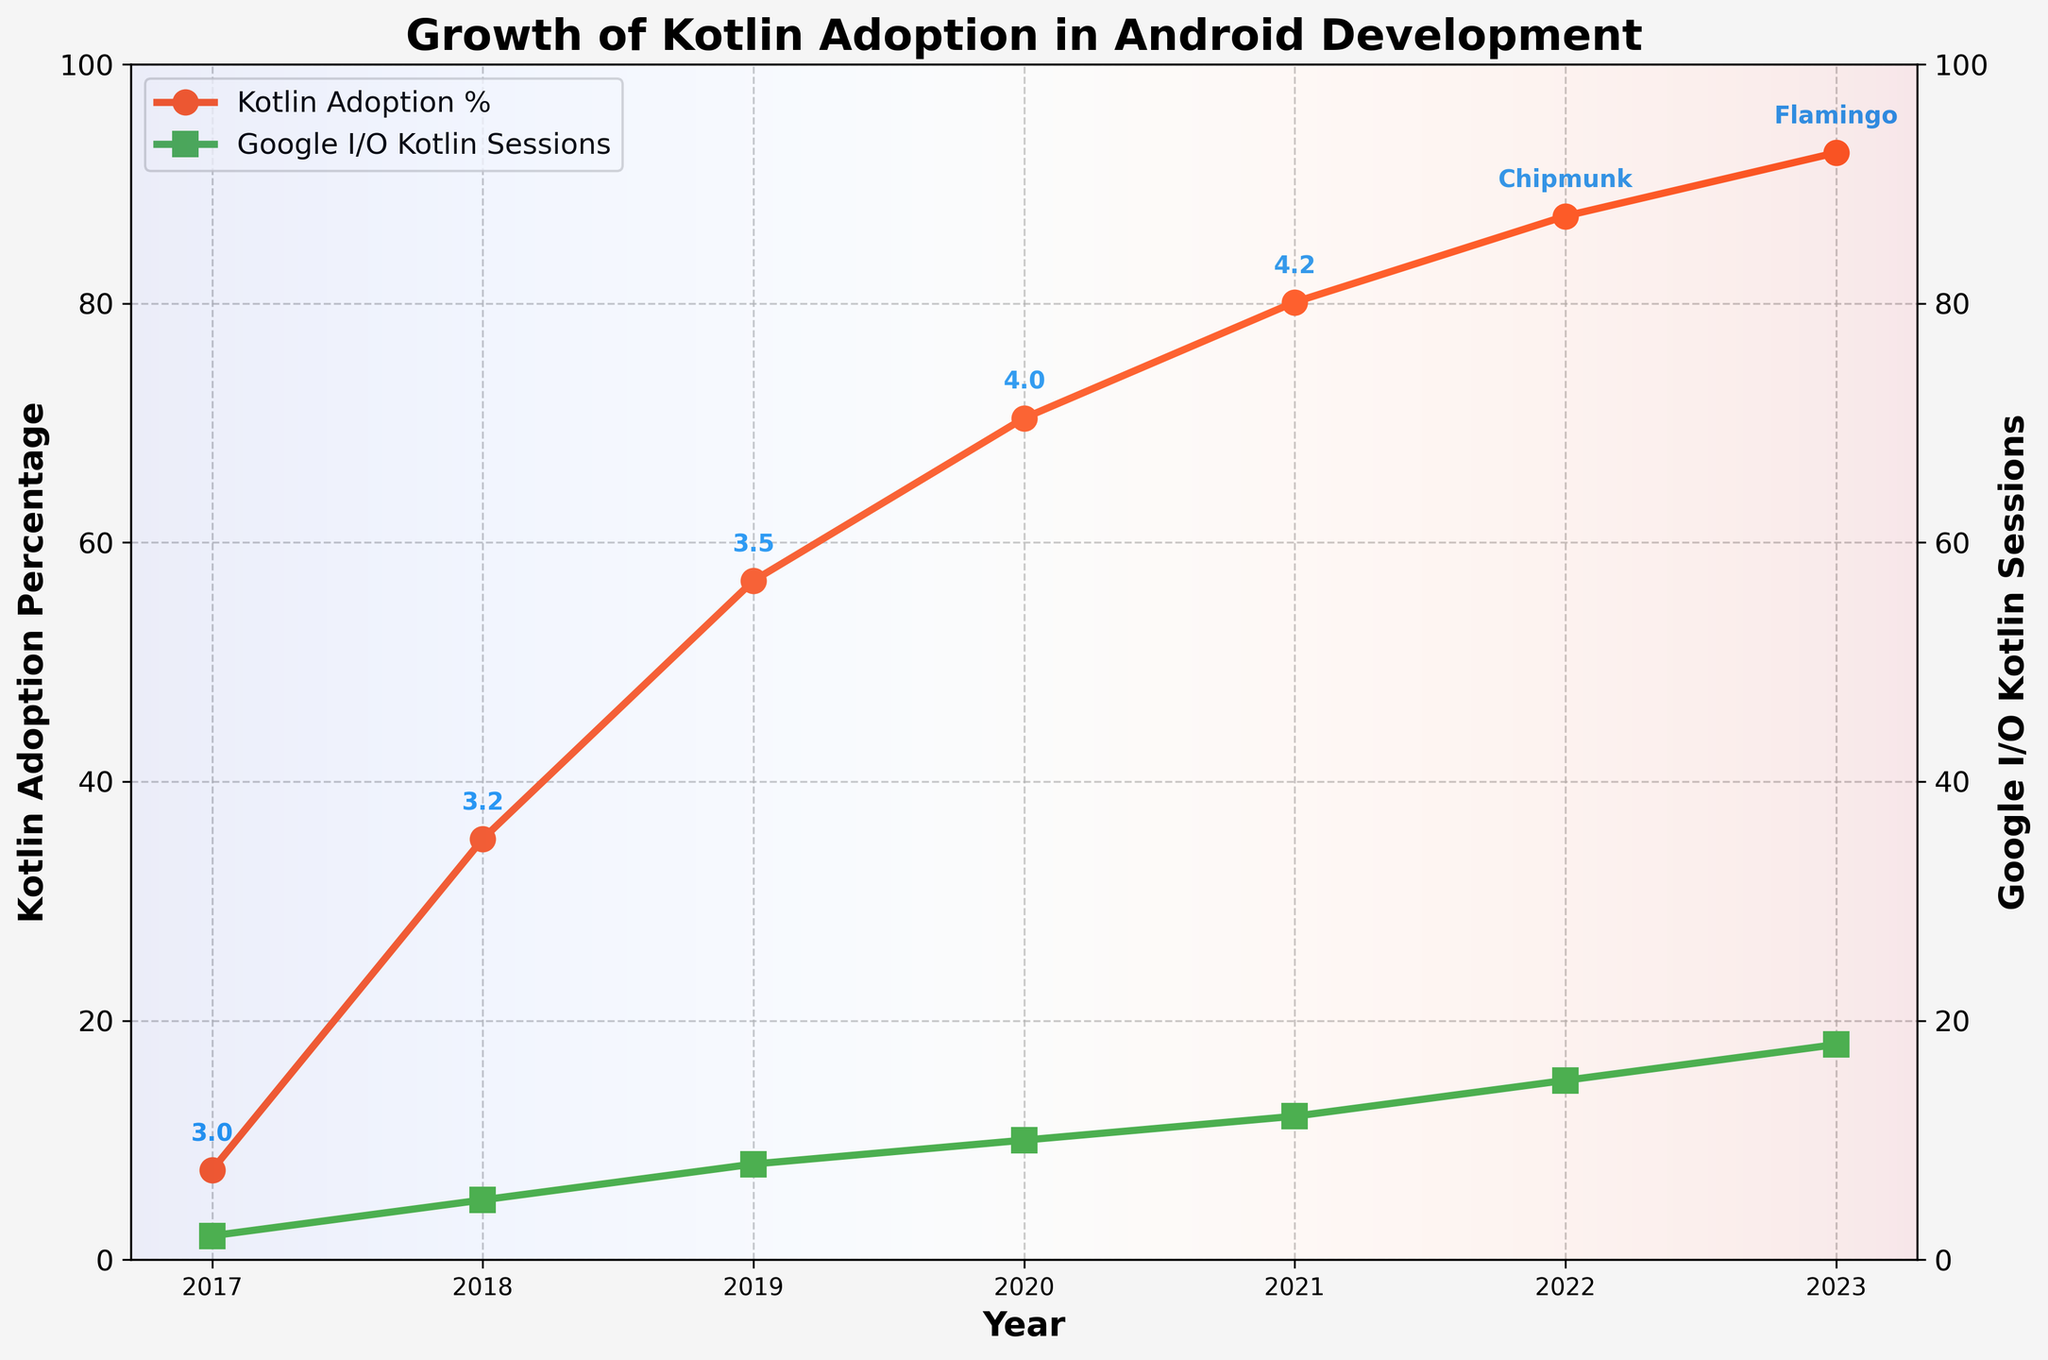What was the Kotlin adoption percentage in 2019? Locate the data point for the year 2019 and refer to the Kotlin adoption percentage. The percentage is marked with a red line and a point labeled 2019.
Answer: 56.8 How many Google I/O Kotlin sessions were there in 2021? Check the second y-axis (right side) which represents the Google I/O Kotlin sessions and locate the point for the year 2021. The value is shown by the green line and a point labeled 2021.
Answer: 12 In which year did the Kotlin adoption percentage surpass 50%? Identify the point on the red line where the Kotlin adoption percentage exceeds 50%. This happens between 2018 and 2019. Checking the points, it is clear that 2019 is the year.
Answer: 2019 By how much did the Kotlin adoption percentage increase from 2017 to 2020? The Kotlin adoption percentage in 2017 was 7.5% and in 2020 it was 70.4%. Subtract the 2017 value from the 2020 value: 70.4 - 7.5.
Answer: 62.9 Which year had a higher Kotlin adoption percentage, 2022 or 2023, and by how much? Compare the adoption percentages for 2022 (87.3%) and 2023 (92.6%). Subtract the 2022 value from the 2023 value: 92.6 - 87.3.
Answer: 2023 by 5.3 What is the relationship between the number of Google I/O Kotlin sessions and Kotlin adoption percentage over the years? Observe the trends of both the green and the red lines. Both metrics are increasing over time, suggesting a positive correlation. Generally, as the number of Kotlin sessions increases, the adoption percentage also rises.
Answer: Positive correlation Which Android Studio version was introduced when Kotlin adoption was around 80%? Find the point where Kotlin adoption is around 80%. This occurs in 2021. The corresponding Android Studio version is labeled at this point.
Answer: 4.2 How much did the number of Google I/O Kotlin sessions increase from 2017 to 2023? Google I/O Kotlin sessions in 2017 were 2 and in 2023 they are 18. Subtract the 2017 value from the 2023 value: 18 - 2.
Answer: 16 In which year did Android Studio version "Flamingo" get introduced according to the plot? Android Studio versions are annotated at each point. Locate the annotation "Flamingo", which is found at the 2023 point.
Answer: 2023 What can be inferred about the Kotlin adoption trend from 2017 to 2023? The Kotlin adoption percentage increases consistently from 7.5% in 2017 to 92.6% in 2023, indicating a steep and steady rise in adoption over these years.
Answer: Steady increase 